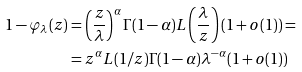<formula> <loc_0><loc_0><loc_500><loc_500>1 - \varphi _ { \lambda } ( z ) & = \left ( \frac { z } { \lambda } \right ) ^ { \alpha } \Gamma ( 1 - \alpha ) L \left ( \frac { \lambda } { z } \right ) ( 1 + o ( 1 ) ) = \\ & = z ^ { \alpha } L ( 1 / z ) \Gamma ( 1 - \alpha ) \lambda ^ { - \alpha } ( 1 + o ( 1 ) )</formula> 